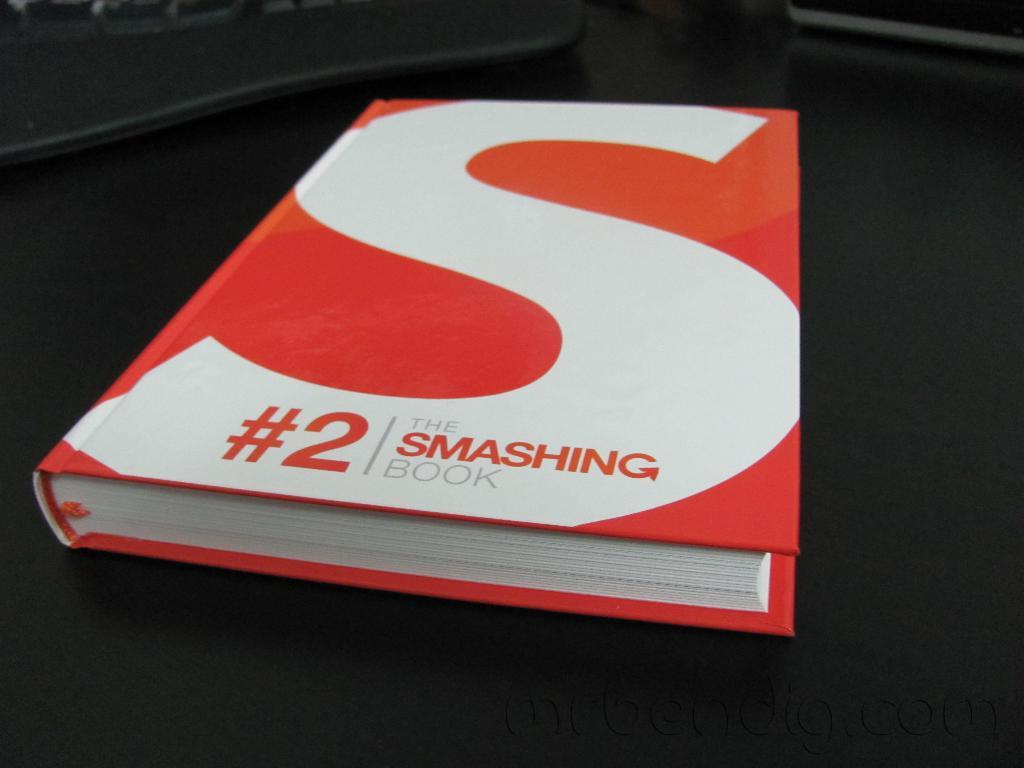<image>
Share a concise interpretation of the image provided. A book with the #2 and a big S on the cover. 